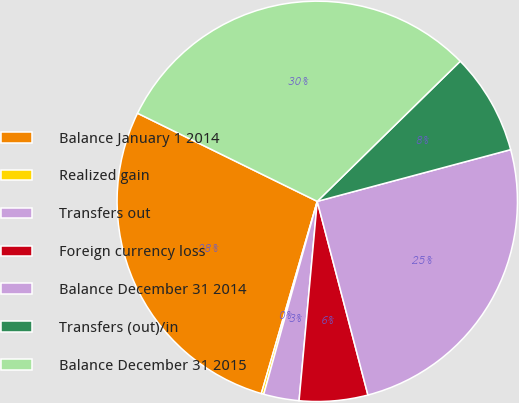Convert chart. <chart><loc_0><loc_0><loc_500><loc_500><pie_chart><fcel>Balance January 1 2014<fcel>Realized gain<fcel>Transfers out<fcel>Foreign currency loss<fcel>Balance December 31 2014<fcel>Transfers (out)/in<fcel>Balance December 31 2015<nl><fcel>27.75%<fcel>0.2%<fcel>2.86%<fcel>5.52%<fcel>25.09%<fcel>8.18%<fcel>30.41%<nl></chart> 